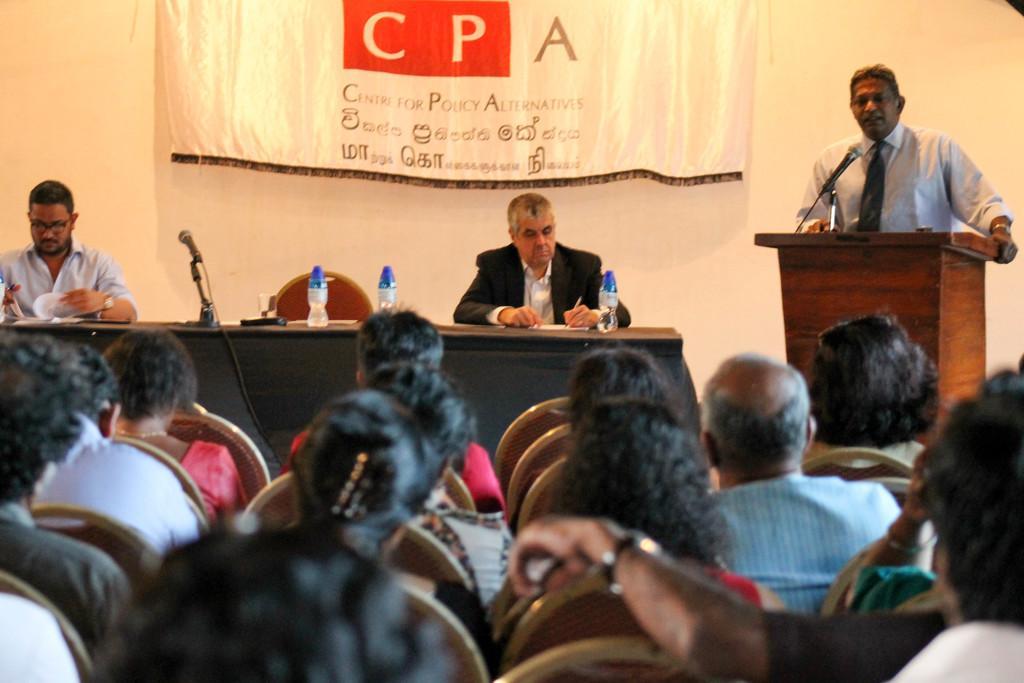Describe this image in one or two sentences. In this image there are people, chairs, tables, podium, banner and wall. Banner is on the wall. People are sitting on chairs. On the table there are bottles, mic, glass and objects. In-front of that person there is a podium along with mic. Something is written on the banner. 